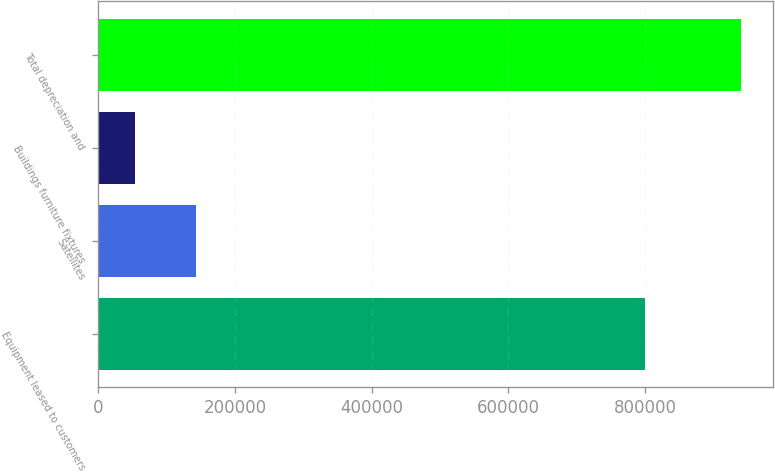Convert chart to OTSL. <chart><loc_0><loc_0><loc_500><loc_500><bar_chart><fcel>Equipment leased to customers<fcel>Satellites<fcel>Buildings furniture fixtures<fcel>Total depreciation and<nl><fcel>799169<fcel>142994<fcel>54434<fcel>940033<nl></chart> 